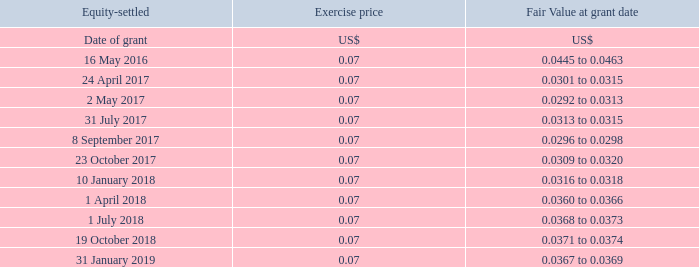5.3.4 HOOQ's share options - equity-settled arrangement
In December 2015, HOOQ Digital Pte. Ltd. (“HOOQ”), a 65%-owned subsidiary of the Company, implemented the HOOQ Digital Employee Share Option Scheme (the “Scheme”). Selected employees (including executive directors) of HOOQ and/or its subsidiaries are granted options to purchase ordinary shares of HOOQ.
Options are exercisable at a price no less than 100% of the fair value of the ordinary shares of HOOQ on the date of grant, and are scheduled to be fully vested 4 years from the vesting commencement date.
Options are exercisable at a price no less than 100% of the fair value of the ordinary shares of HOOQ on the date of grant, and are scheduled to be fully vested 4 years from the vesting commencement date.
The grant dates, exercise prices and fair values of the share options were as follows –
The term of each option granted is 10 years from the date of grant.
The fair values for the share options granted were estimated using the Black-Scholes pricing model.
From 1 April 2018 to 31 March 2019, options in respect of an aggregate of 9.6 million of ordinary shares in HOOQ have been granted. As at 31 March 2019, options in respect of an aggregate of 43.3 million of ordinary shares in HOOQ are outstanding.
What model was used to calculate the fair value of the share options granted? Black-scholes pricing model. What can the employees do with the granted options? Purchase ordinary shares of hooq. How long does the options take to become fully vested? 4 years from the vesting commencement date. On how many different occasions did Singtel grant share options in 2017? 24 April## 2 May## 31 July## 8 September## 23 October
Answer: 5. As at 31 March 2017, options in respect of how many ordinary shares in HOOQ were outstanding? 
Answer scale should be: million. 43.3 - 9.6
Answer: 33.7. When does the term of the option granted on 31 January 2019 end? 31 January 2019 + 10 years
Answer: 31 January 2029. 